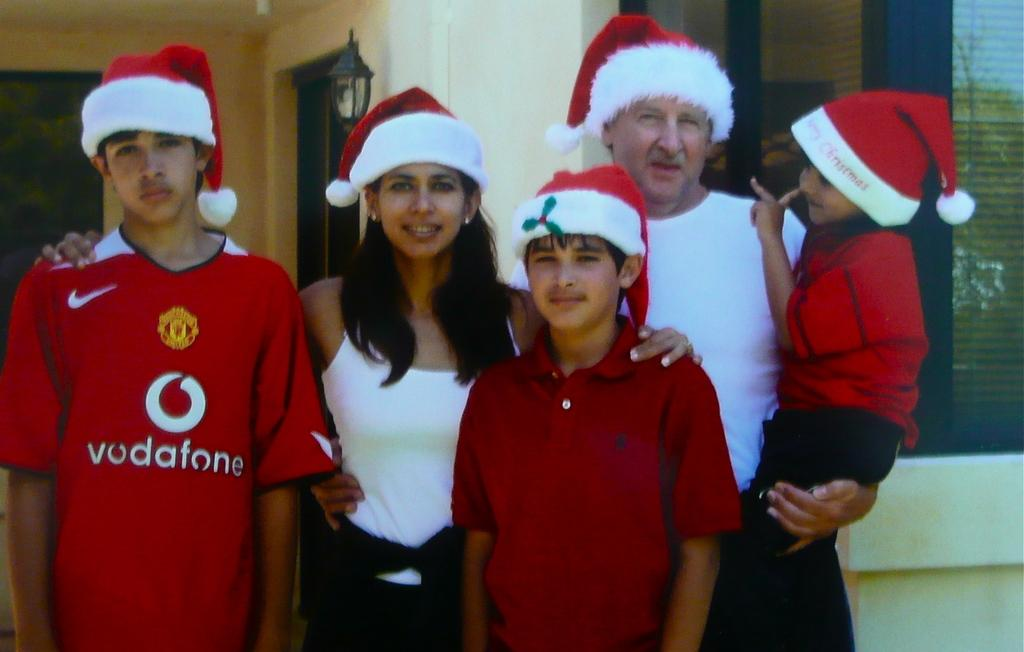<image>
Relay a brief, clear account of the picture shown. A boy in a Vodafone shirt is posing with four other people all in Santa hats. 